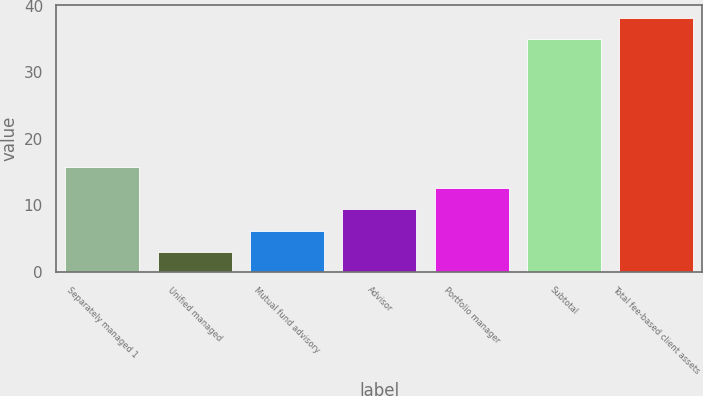Convert chart to OTSL. <chart><loc_0><loc_0><loc_500><loc_500><bar_chart><fcel>Separately managed 1<fcel>Unified managed<fcel>Mutual fund advisory<fcel>Advisor<fcel>Portfolio manager<fcel>Subtotal<fcel>Total fee-based client assets<nl><fcel>15.8<fcel>3<fcel>6.2<fcel>9.4<fcel>12.6<fcel>35<fcel>38.2<nl></chart> 